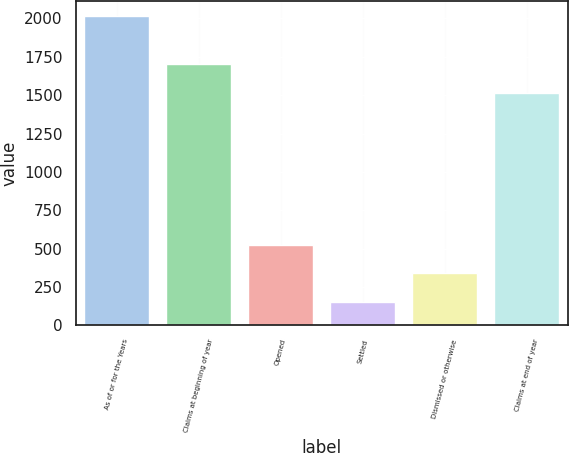Convert chart. <chart><loc_0><loc_0><loc_500><loc_500><bar_chart><fcel>As of or for the Years<fcel>Claims at beginning of year<fcel>Opened<fcel>Settled<fcel>Dismissed or otherwise<fcel>Claims at end of year<nl><fcel>2013<fcel>1702.9<fcel>525.8<fcel>154<fcel>339.9<fcel>1517<nl></chart> 